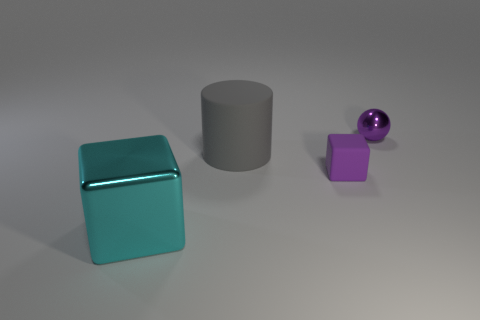There is a purple rubber thing that is the same shape as the big cyan metallic object; what is its size?
Your answer should be compact. Small. Do the cylinder and the large cube have the same color?
Offer a very short reply. No. Is there any other thing that is the same shape as the small rubber thing?
Give a very brief answer. Yes. There is a metal object left of the large gray matte object; are there any large cyan metal objects that are behind it?
Make the answer very short. No. There is another small thing that is the same shape as the cyan metal object; what is its color?
Make the answer very short. Purple. How many cubes are the same color as the small sphere?
Offer a terse response. 1. What color is the thing that is in front of the purple object in front of the shiny object behind the purple matte block?
Make the answer very short. Cyan. Is the material of the big cyan cube the same as the gray cylinder?
Your answer should be compact. No. Does the big gray matte thing have the same shape as the cyan object?
Your answer should be very brief. No. Are there the same number of purple objects that are in front of the large cyan metallic cube and small matte things behind the gray cylinder?
Offer a very short reply. Yes. 